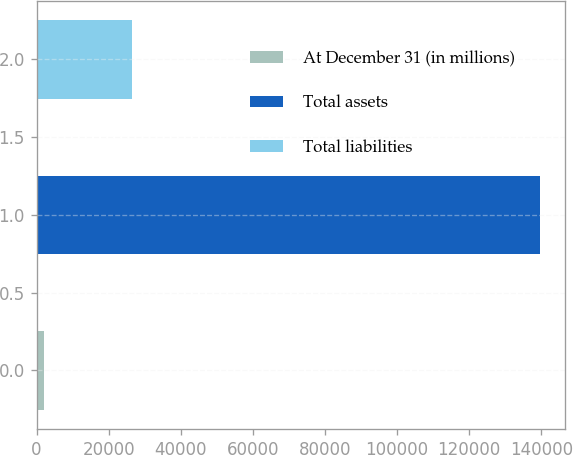<chart> <loc_0><loc_0><loc_500><loc_500><bar_chart><fcel>At December 31 (in millions)<fcel>Total assets<fcel>Total liabilities<nl><fcel>2012<fcel>139681<fcel>26529<nl></chart> 